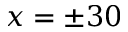Convert formula to latex. <formula><loc_0><loc_0><loc_500><loc_500>x = \pm 3 0</formula> 